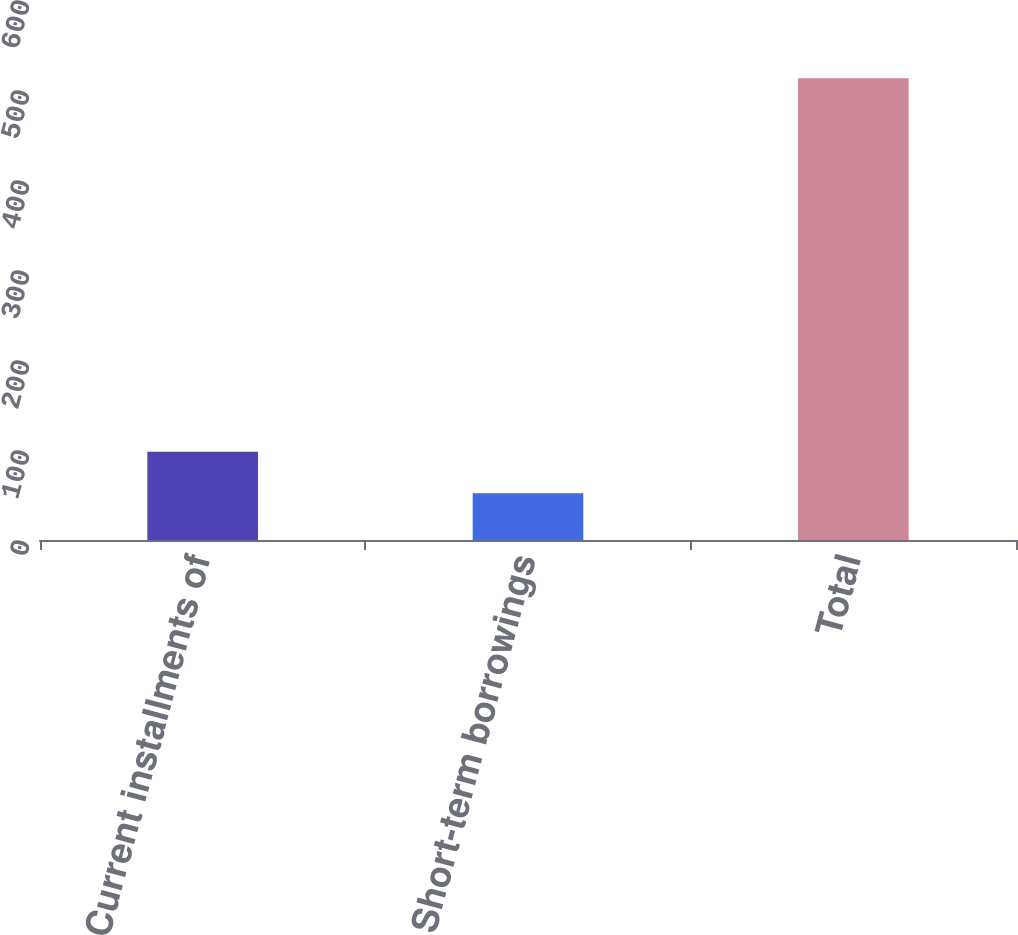<chart> <loc_0><loc_0><loc_500><loc_500><bar_chart><fcel>Current installments of<fcel>Short-term borrowings<fcel>Total<nl><fcel>98.1<fcel>52<fcel>513<nl></chart> 